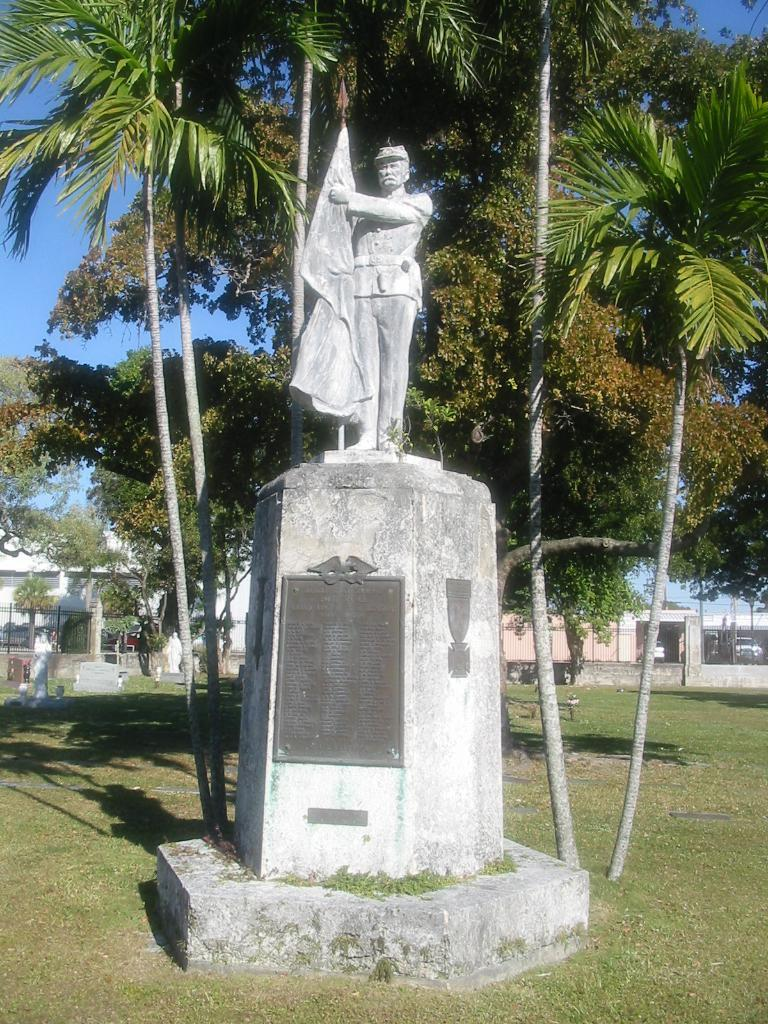What is the main subject in the image? There is a statue in the image. What type of vegetation is present in the image? There are trees and green grass in the image. What can be seen in the background of the image? There are buildings in the background of the image. What is visible in the sky in the image? There are clouds in the sky in the image. Who is the manager of the statue in the image? There is no manager mentioned or implied in the image, as it is a statue and not a person or organization. 